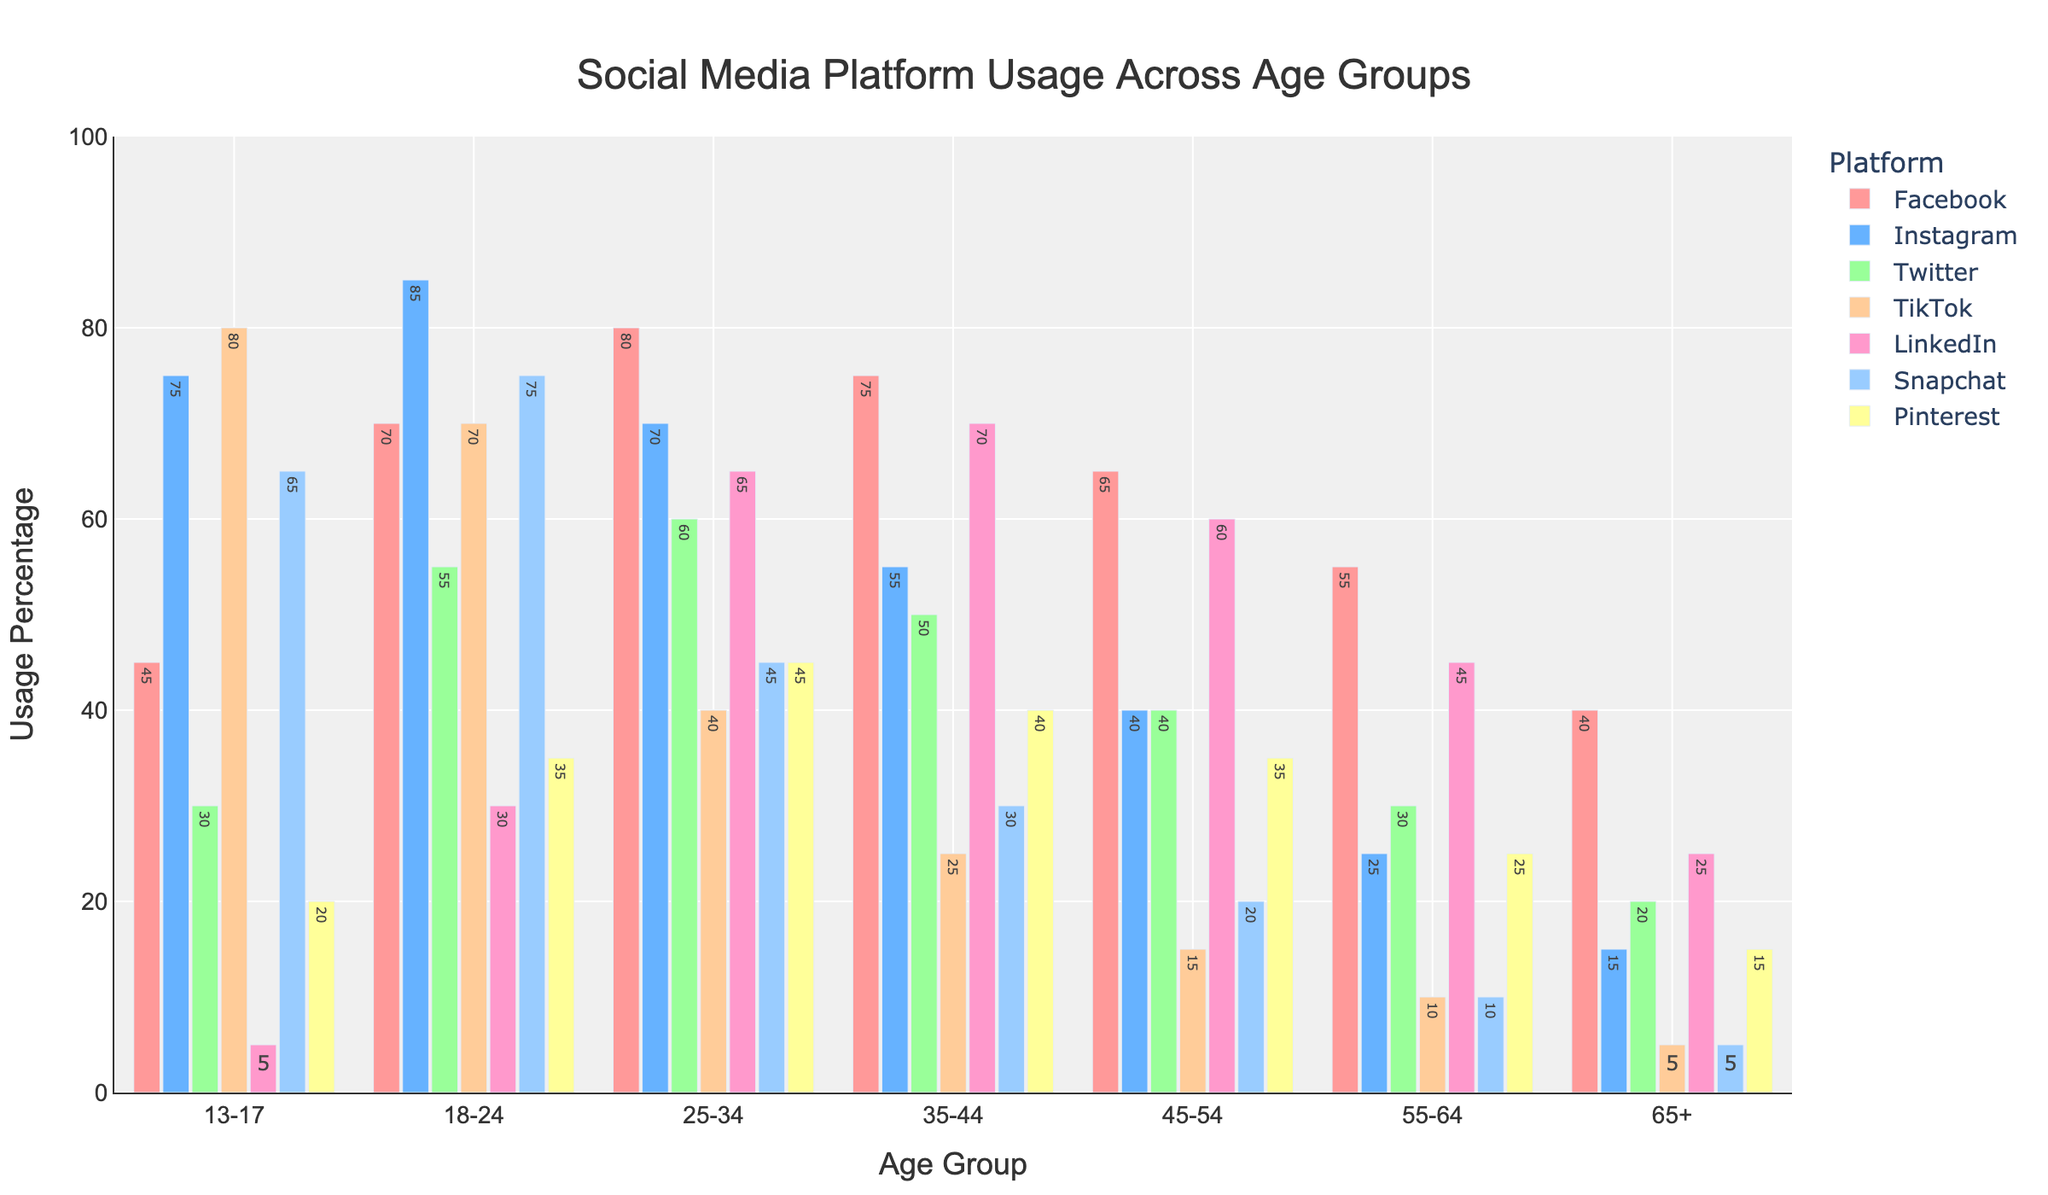What is the most popular social media platform among the 18-24 age group? Look at the bar heights for each platform in the 18-24 age group. The tallest bar represents the most popular platform. The bar for Instagram is the tallest in this age group.
Answer: Instagram Which age group uses TikTok the most? Compare the heights of the TikTok bars across all age groups. The age group with the highest bar represents the highest usage. The 13-17 age group has the tallest bar for TikTok.
Answer: 13-17 What is the least used social media platform among the 65+ age group? Look at the bar heights for each platform in the 65+ age group. The shortest bar represents the least used platform. The bar for TikTok is the shortest in this age group.
Answer: TikTok Between the 25-34 and 35-44 age groups, which uses LinkedIn more and by how much? Compare the heights of the LinkedIn bars for the 25-34 and 35-44 age groups. The 35-44 age group has a higher bar for LinkedIn. The difference in heights represents the difference in usage percentage. The 35-44 age group uses LinkedIn 70% while the 25-34 age group uses it 65%, so the difference is 70 - 65 = 5%.
Answer: 35-44, 5% What is the total usage percentage of Snapchat for all age groups combined? Add the heights of all the Snapchat bars across all age groups: 13-17 (65), 18-24 (75), 25-34 (45), 35-44 (30), 45-54 (20), 55-64 (10), 65+ (5). The total usage percentage is 65 + 75 + 45 + 30 + 20 + 10 + 5 = 250%.
Answer: 250% Which social media platform shows the largest drop in usage from the 18-24 age group to the 25-34 age group? Calculate the difference in usage for each platform between the 18-24 and 25-34 age groups. The platform with the largest difference is Instagram with 85 - 70 = 15.
Answer: Instagram Is the usage of Pinterest in the 45-54 age group higher than in the 13-17 age group? Compare the heights of the Pinterest bars for both age groups. The 45-54 age group has a bar of 35, higher than the 13-17 age group which has a bar of 20.
Answer: Yes Which age group has the closest usage percentage for Facebook and Twitter? Calculate the difference between Facebook and Twitter usage for each age group and identify the smallest difference. For the 45-54 age group, the difference is 65 - 40 = 25, which is the smallest among all age groups.
Answer: 45-54 What is the average usage percentage of LinkedIn across all age groups? Add the heights of all the LinkedIn bars across all age groups and then divide by the number of age groups (7): (5 + 30 + 65 + 70 + 60 + 45 + 25) / 7 = 300 / 7 ≈ 42.86%.
Answer: 42.86% Among all the platforms, which one has the most consistent usage across the age groups? Evaluate the variation in bar heights for each platform. Facebook's bars have the least variation from the tallest to the shortest (80 to 40).
Answer: Facebook 